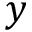Convert formula to latex. <formula><loc_0><loc_0><loc_500><loc_500>y</formula> 